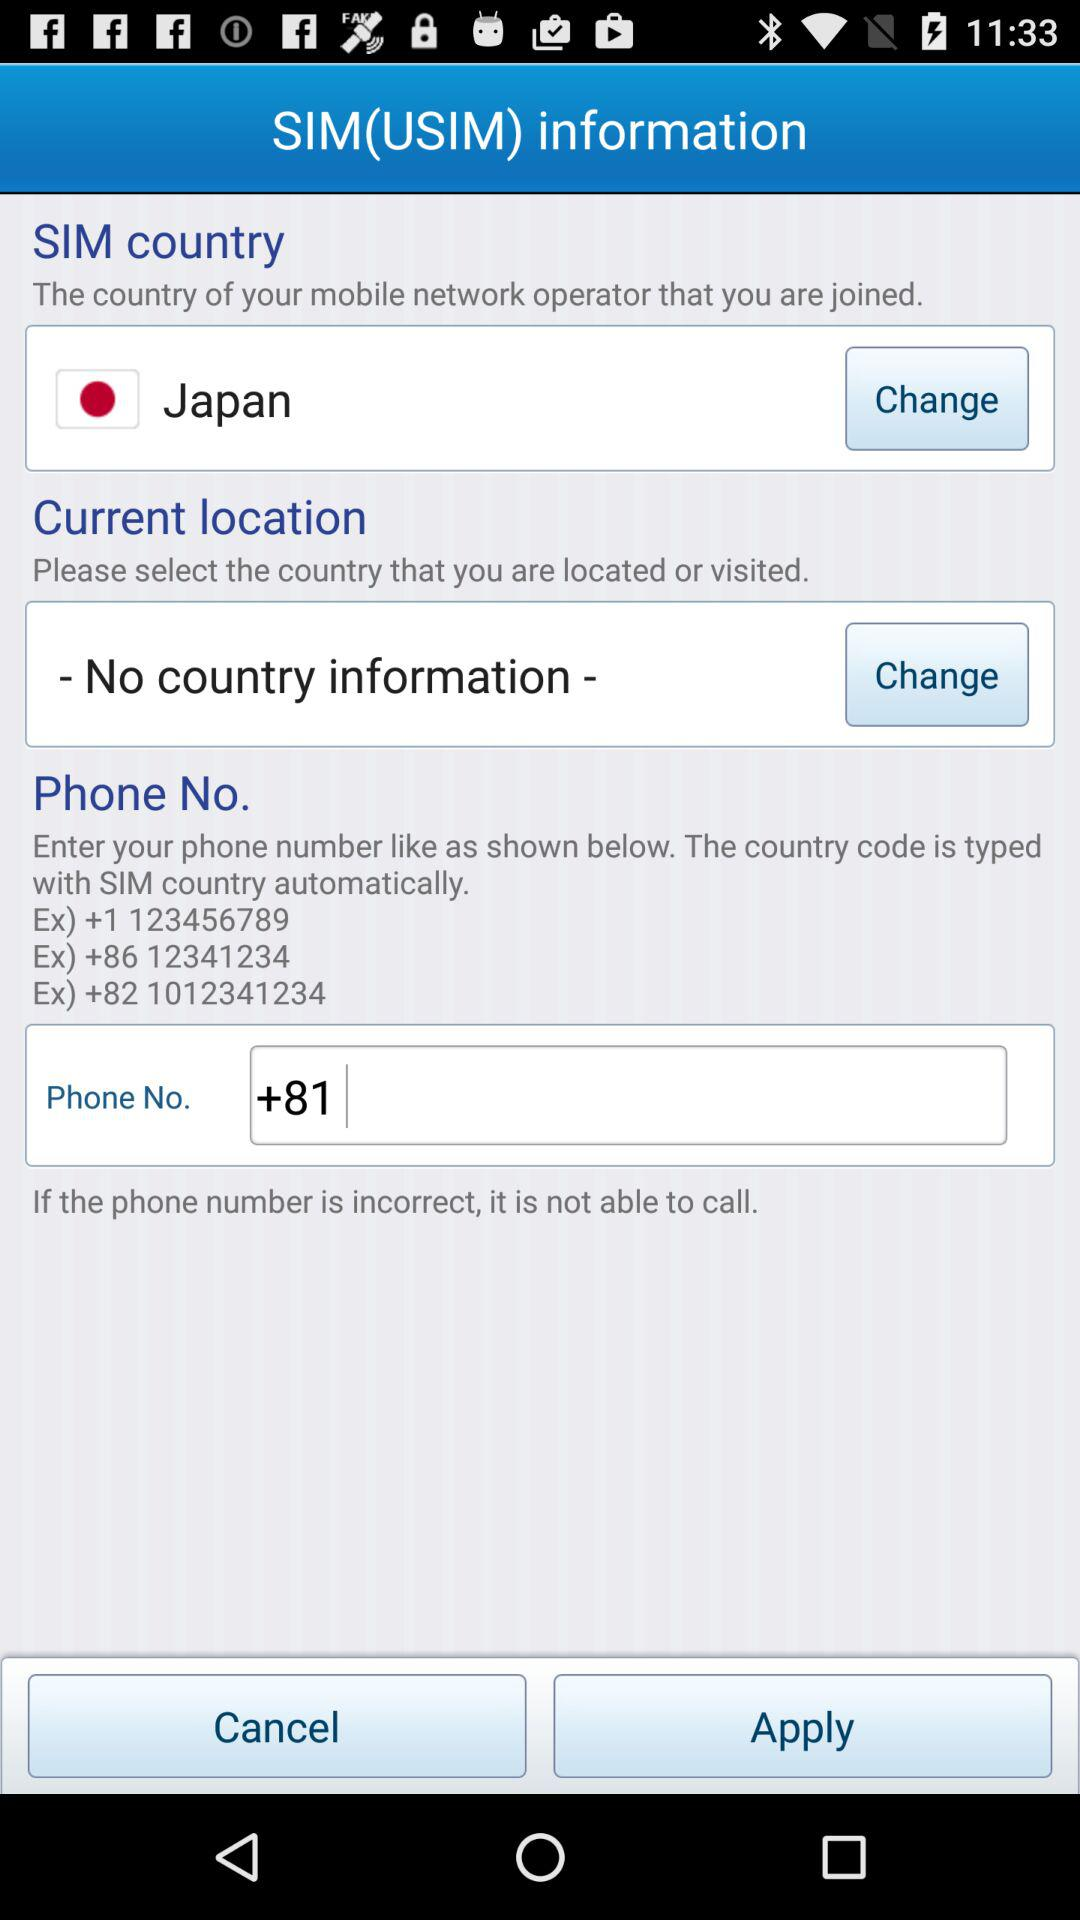What is the "SIM country" name? The "SIM country" name is Japan. 